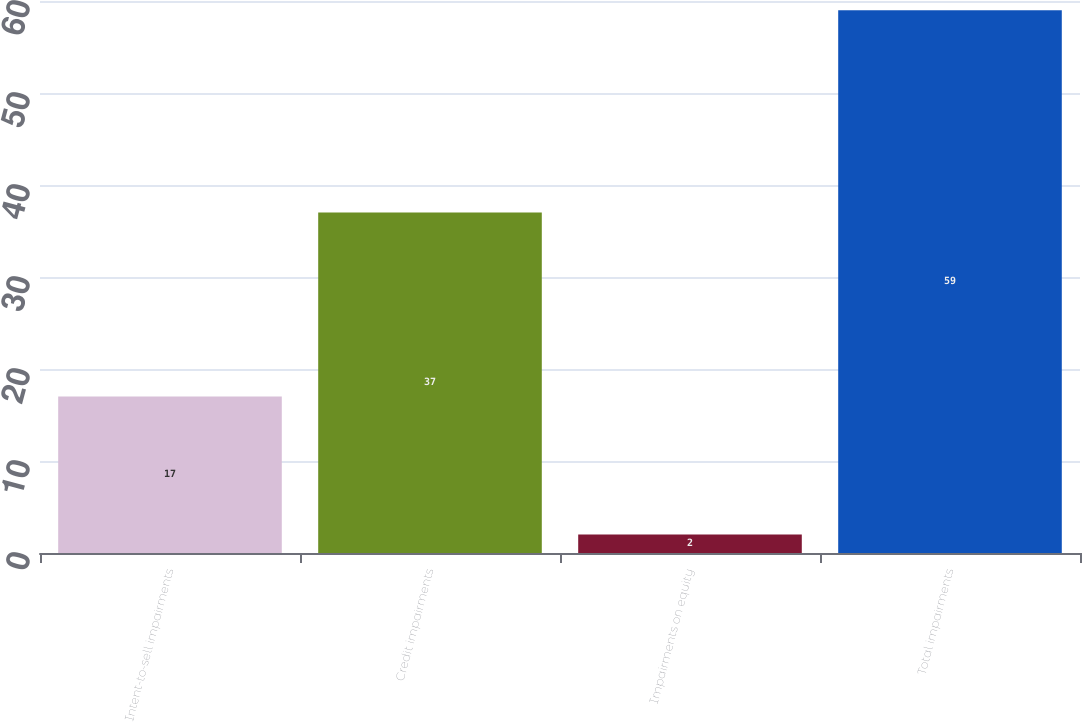Convert chart to OTSL. <chart><loc_0><loc_0><loc_500><loc_500><bar_chart><fcel>Intent-to-sell impairments<fcel>Credit impairments<fcel>Impairments on equity<fcel>Total impairments<nl><fcel>17<fcel>37<fcel>2<fcel>59<nl></chart> 